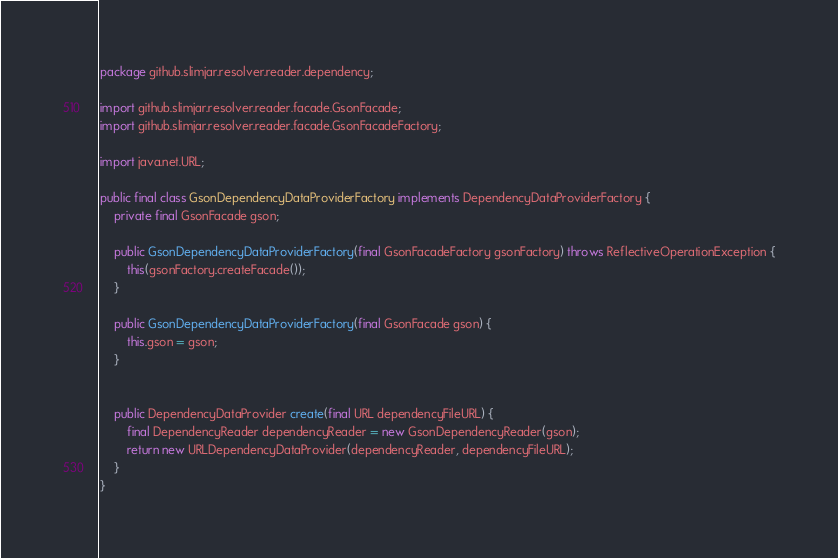<code> <loc_0><loc_0><loc_500><loc_500><_Java_>package github.slimjar.resolver.reader.dependency;

import github.slimjar.resolver.reader.facade.GsonFacade;
import github.slimjar.resolver.reader.facade.GsonFacadeFactory;

import java.net.URL;

public final class GsonDependencyDataProviderFactory implements DependencyDataProviderFactory {
    private final GsonFacade gson;

    public GsonDependencyDataProviderFactory(final GsonFacadeFactory gsonFactory) throws ReflectiveOperationException {
        this(gsonFactory.createFacade());
    }

    public GsonDependencyDataProviderFactory(final GsonFacade gson) {
        this.gson = gson;
    }


    public DependencyDataProvider create(final URL dependencyFileURL) {
        final DependencyReader dependencyReader = new GsonDependencyReader(gson);
        return new URLDependencyDataProvider(dependencyReader, dependencyFileURL);
    }
}
</code> 